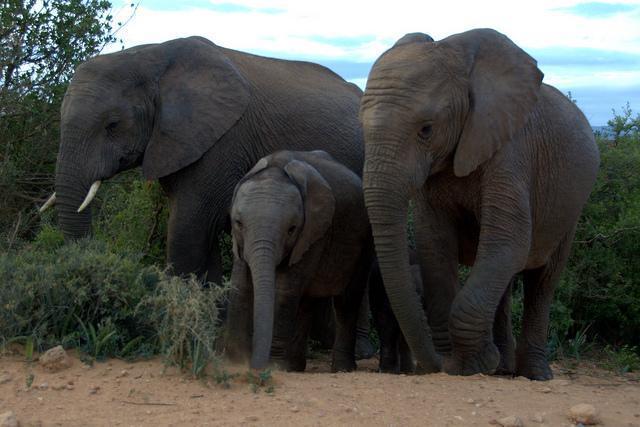How many elephants can you see?
Give a very brief answer. 3. How many buses are there?
Give a very brief answer. 0. 